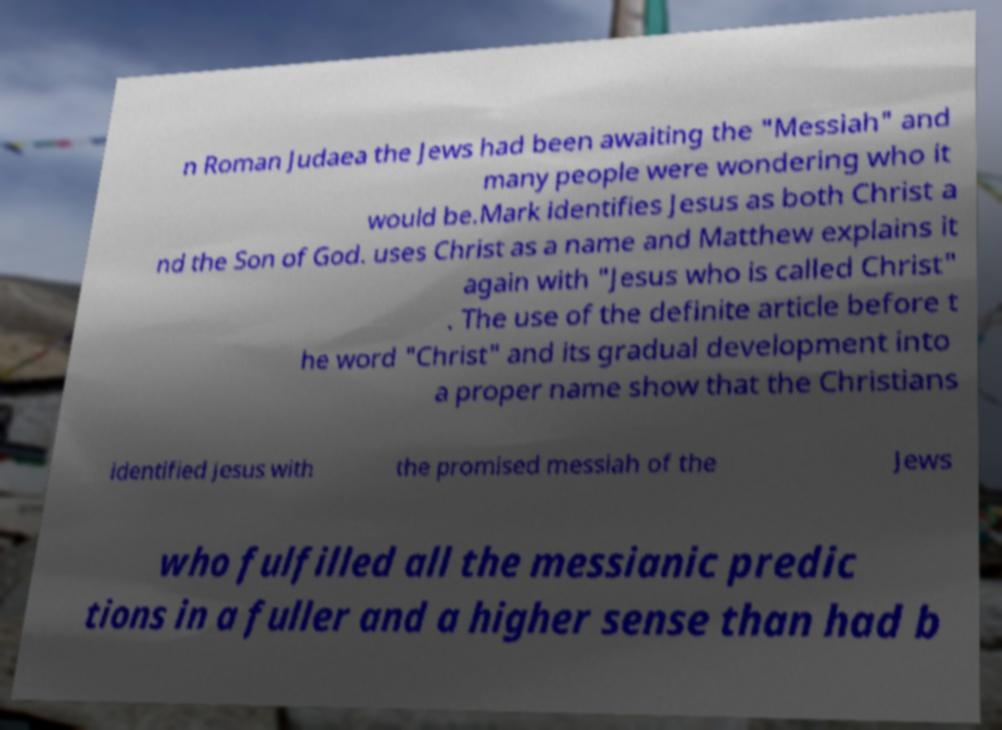Could you extract and type out the text from this image? n Roman Judaea the Jews had been awaiting the "Messiah" and many people were wondering who it would be.Mark identifies Jesus as both Christ a nd the Son of God. uses Christ as a name and Matthew explains it again with "Jesus who is called Christ" . The use of the definite article before t he word "Christ" and its gradual development into a proper name show that the Christians identified Jesus with the promised messiah of the Jews who fulfilled all the messianic predic tions in a fuller and a higher sense than had b 